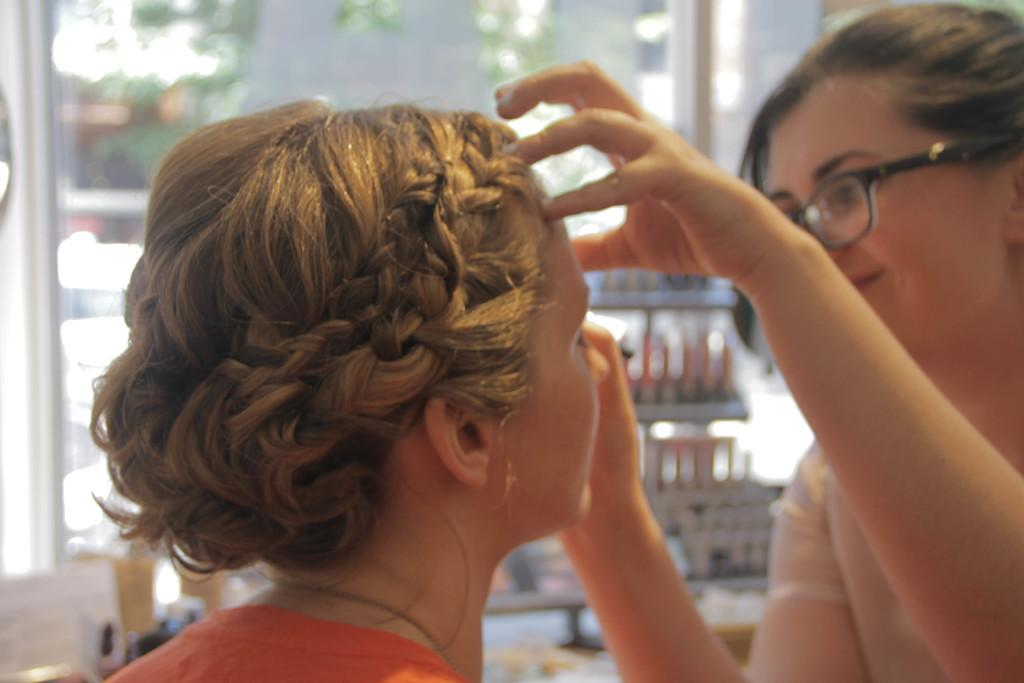Where is the woman located in the image? The woman is in the right corner of the image. What is the woman in the right corner doing? The woman in the right corner has her hands on the face of another woman in front of her. What else can be seen in the background of the image? There are other objects in the background of the image. What type of polish is the woman applying to her nails in the image? There is no indication in the image that the woman is applying polish to her nails, as her hands are on the face of another woman. 